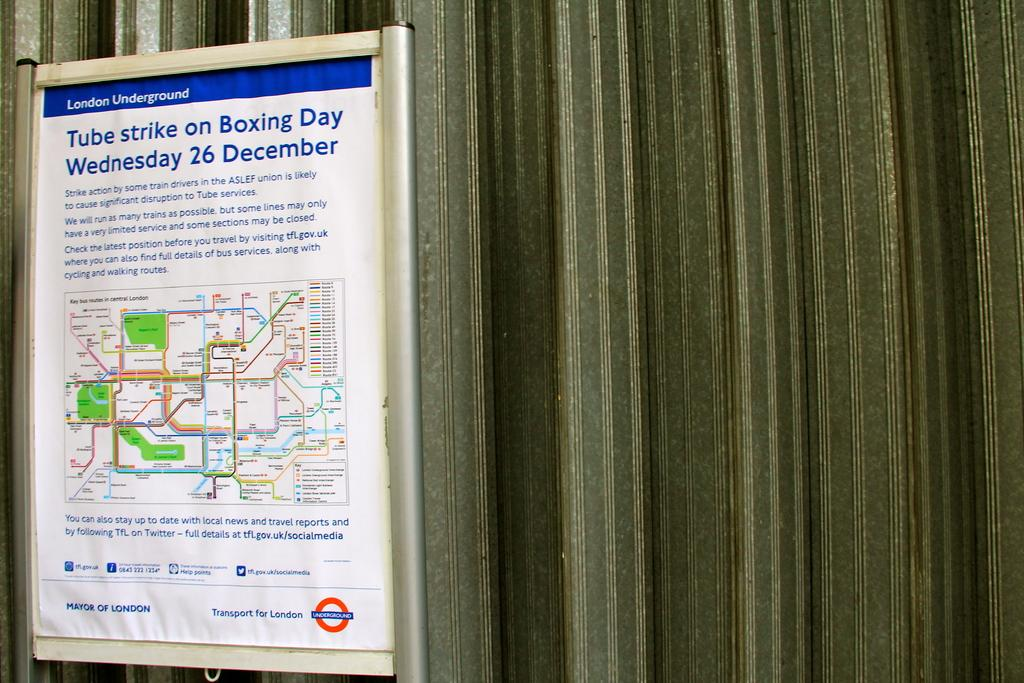<image>
Offer a succinct explanation of the picture presented. poster for london underground showing a tube strike on boxing day 